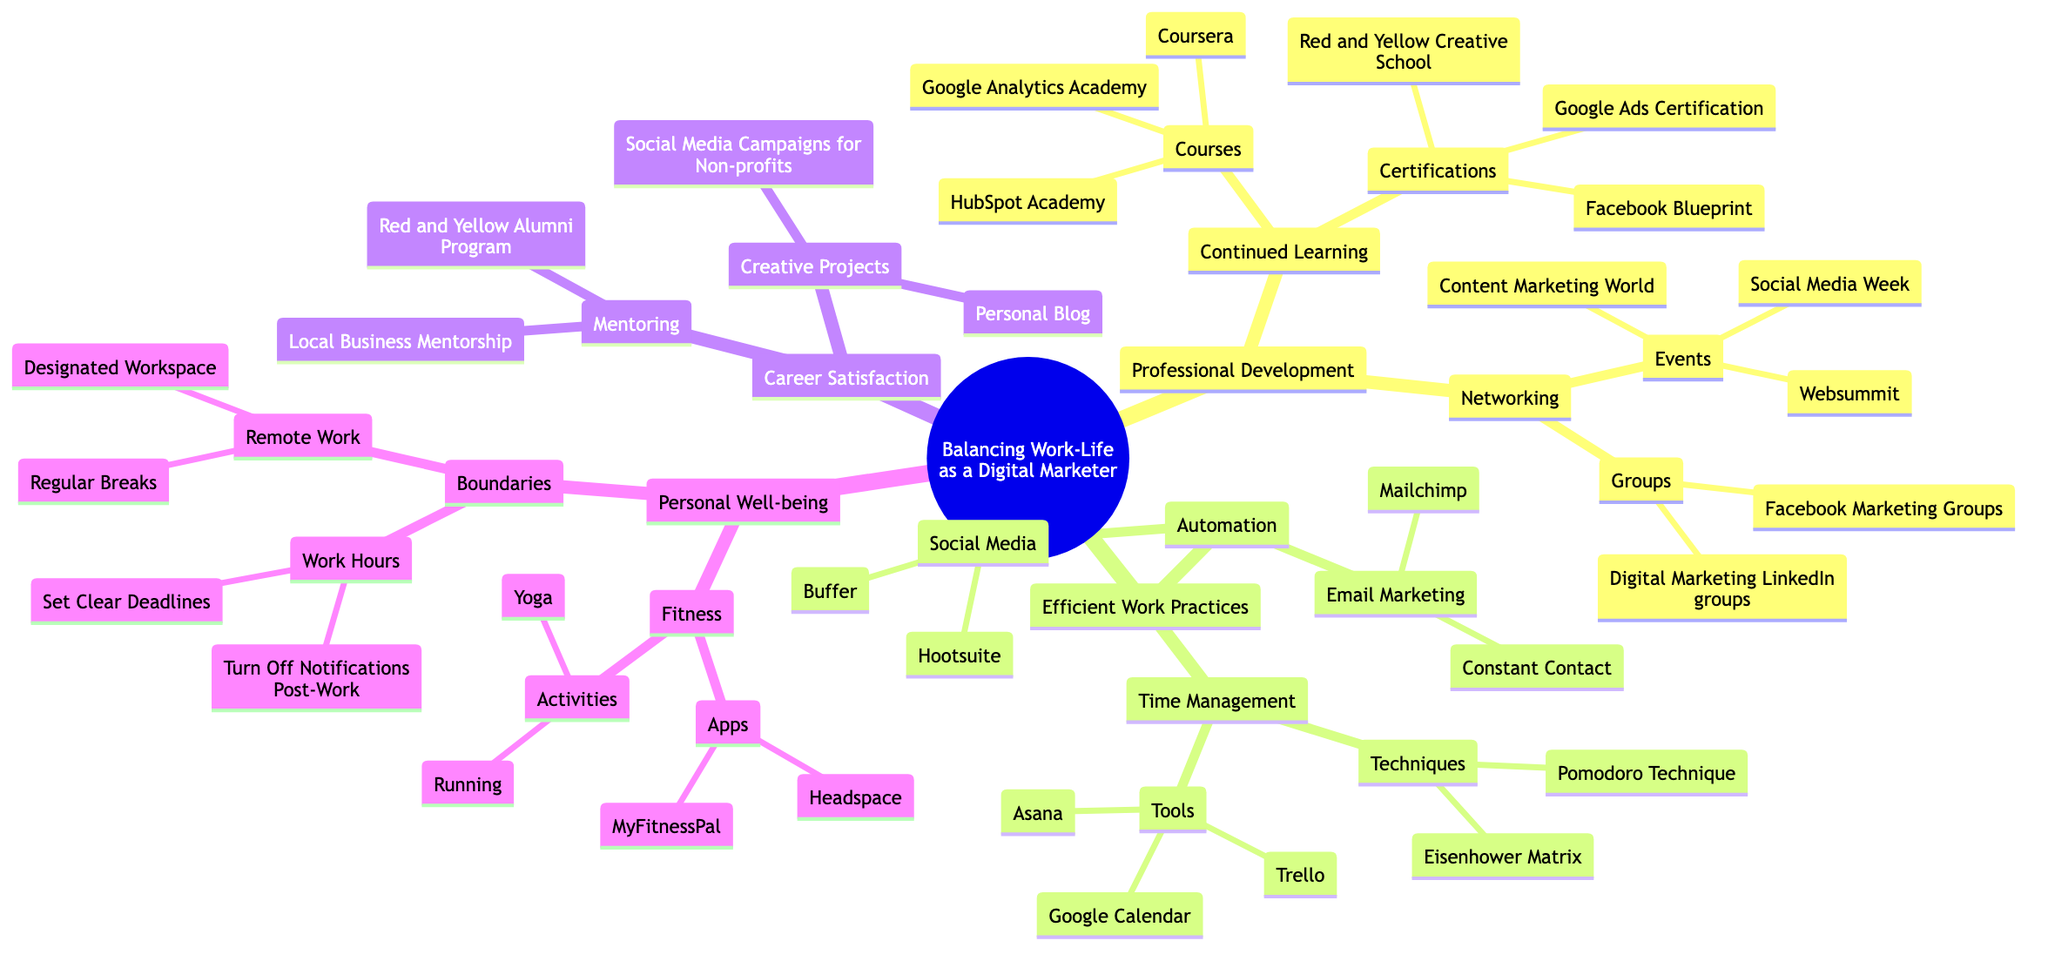What are the three areas of focus under Professional Development? The diagram shows three main branches under Professional Development: Continued Learning, Networking, and Certifications.
Answer: Continued Learning, Networking Which techniques are suggested for Time Management? The diagram lists two techniques under Time Management: Pomodoro Technique and Eisenhower Matrix.
Answer: Pomodoro Technique, Eisenhower Matrix How many courses are mentioned under Continued Learning? By counting the nodes listed under Continued Learning, there are three courses provided: Google Analytics Academy, HubSpot Academy, and Coursera.
Answer: 3 What tools are mentioned for Efficient Work Practices? The diagram states three tools under Efficient Work Practices: Trello, Asana, and Google Calendar, which are clearly labeled in the relevant section.
Answer: Trello, Asana, Google Calendar What does the Personal Well-being section suggest for fitness activities? The Personal Well-being section under Fitness lists two activities: Yoga and Running. This can be directly observed from the diagram.
Answer: Yoga, Running Which two automation tools are included for Email Marketing? The diagram shows two specific automation tools for Email Marketing: Mailchimp and Constant Contact. This can be found under the Automation section.
Answer: Mailchimp, Constant Contact What is one way to set boundaries for work hours? The diagram lists "Set Clear Deadlines" as one of the strategies under Boundaries for work hours, which addresses how to establish limits.
Answer: Set Clear Deadlines How many events are listed under Networking? There are three events mentioned under Networking in the diagram: Websummit, Content Marketing World, and Social Media Week, which can be counted directly.
Answer: 3 What is a suggested app for Fitness tracking? The diagram indicates MyFitnessPal as one of the apps under the Fitness section, thus providing a clear recommendation in the Personal Well-being area.
Answer: MyFitnessPal 